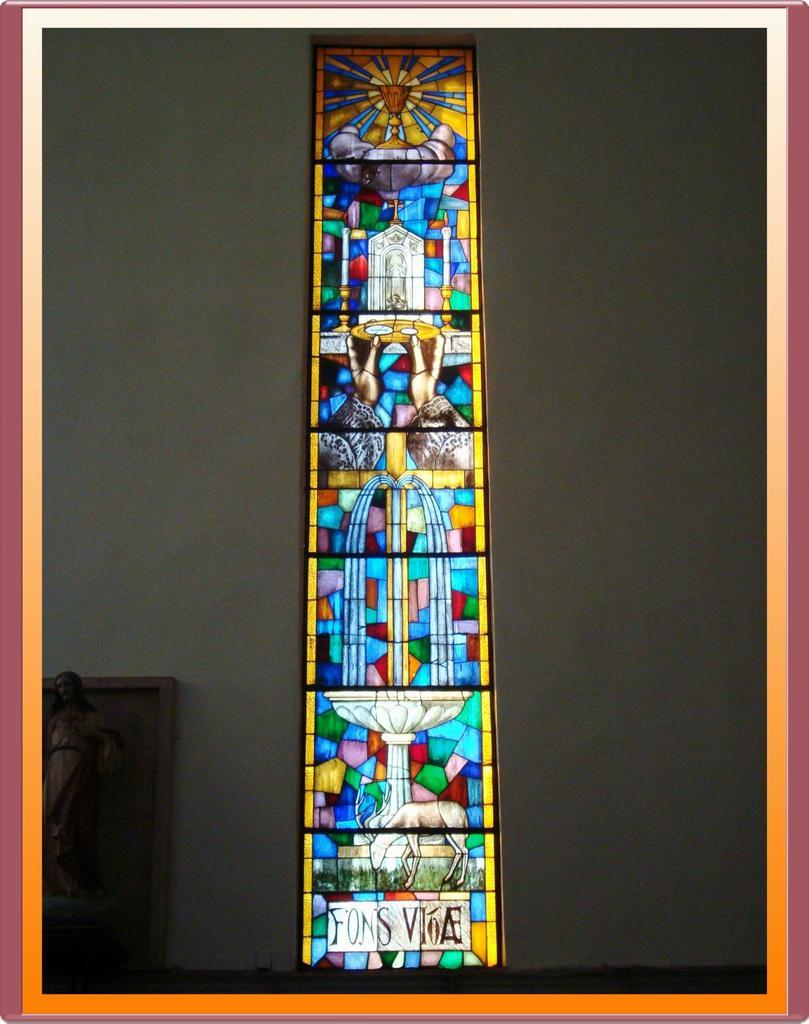What is the main subject in the center of the image? There is a stained glass in the center of the image. How is the stained glass positioned in the image? The stained glass is attached to a wall. What other object can be seen in the image? There is a statue in the bottom left corner of the image. What type of pet is depicted in the stained glass? There is no pet depicted in the stained glass; it is a decorative piece of art. What religion is associated with the stained glass in the image? The image does not provide any information about the religion associated with the stained glass. 